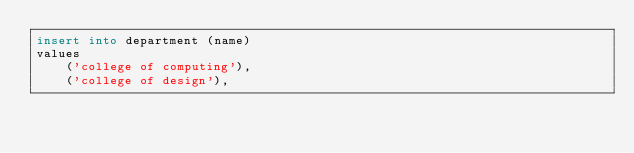Convert code to text. <code><loc_0><loc_0><loc_500><loc_500><_SQL_>insert into department (name)
values
    ('college of computing'),
    ('college of design'),</code> 